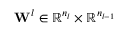Convert formula to latex. <formula><loc_0><loc_0><loc_500><loc_500>W ^ { l } \in \mathbb { R } ^ { n _ { l } } \times \mathbb { R } ^ { n _ { l - 1 } }</formula> 